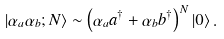Convert formula to latex. <formula><loc_0><loc_0><loc_500><loc_500>\left | \alpha _ { a } \alpha _ { b } ; N \right \rangle \sim \left ( \alpha _ { a } a ^ { \dagger } + \alpha _ { b } b ^ { \dagger } \right ) ^ { N } \left | 0 \right \rangle .</formula> 